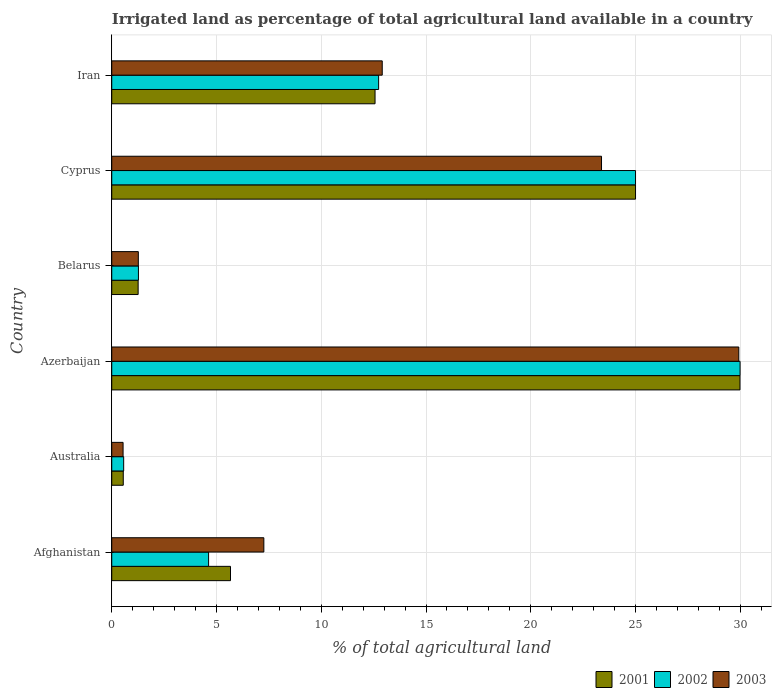How many groups of bars are there?
Your answer should be compact. 6. Are the number of bars per tick equal to the number of legend labels?
Keep it short and to the point. Yes. Are the number of bars on each tick of the Y-axis equal?
Make the answer very short. Yes. How many bars are there on the 6th tick from the top?
Your answer should be compact. 3. How many bars are there on the 6th tick from the bottom?
Offer a very short reply. 3. What is the label of the 3rd group of bars from the top?
Offer a terse response. Belarus. What is the percentage of irrigated land in 2003 in Cyprus?
Ensure brevity in your answer.  23.38. Across all countries, what is the maximum percentage of irrigated land in 2002?
Offer a terse response. 29.99. Across all countries, what is the minimum percentage of irrigated land in 2001?
Give a very brief answer. 0.55. In which country was the percentage of irrigated land in 2001 maximum?
Give a very brief answer. Azerbaijan. What is the total percentage of irrigated land in 2001 in the graph?
Ensure brevity in your answer.  75.03. What is the difference between the percentage of irrigated land in 2001 in Azerbaijan and that in Iran?
Ensure brevity in your answer.  17.42. What is the difference between the percentage of irrigated land in 2001 in Belarus and the percentage of irrigated land in 2002 in Cyprus?
Provide a short and direct response. -23.74. What is the average percentage of irrigated land in 2003 per country?
Keep it short and to the point. 12.55. What is the difference between the percentage of irrigated land in 2003 and percentage of irrigated land in 2002 in Cyprus?
Ensure brevity in your answer.  -1.62. What is the ratio of the percentage of irrigated land in 2003 in Azerbaijan to that in Iran?
Keep it short and to the point. 2.32. Is the difference between the percentage of irrigated land in 2003 in Azerbaijan and Cyprus greater than the difference between the percentage of irrigated land in 2002 in Azerbaijan and Cyprus?
Provide a succinct answer. Yes. What is the difference between the highest and the second highest percentage of irrigated land in 2002?
Provide a succinct answer. 4.99. What is the difference between the highest and the lowest percentage of irrigated land in 2001?
Your response must be concise. 29.44. Is the sum of the percentage of irrigated land in 2002 in Belarus and Cyprus greater than the maximum percentage of irrigated land in 2003 across all countries?
Give a very brief answer. No. What does the 2nd bar from the top in Afghanistan represents?
Make the answer very short. 2002. How many bars are there?
Give a very brief answer. 18. How many countries are there in the graph?
Provide a succinct answer. 6. Are the values on the major ticks of X-axis written in scientific E-notation?
Provide a short and direct response. No. Does the graph contain grids?
Offer a very short reply. Yes. Where does the legend appear in the graph?
Provide a short and direct response. Bottom right. What is the title of the graph?
Ensure brevity in your answer.  Irrigated land as percentage of total agricultural land available in a country. What is the label or title of the X-axis?
Offer a terse response. % of total agricultural land. What is the label or title of the Y-axis?
Offer a terse response. Country. What is the % of total agricultural land of 2001 in Afghanistan?
Offer a terse response. 5.67. What is the % of total agricultural land of 2002 in Afghanistan?
Offer a very short reply. 4.62. What is the % of total agricultural land in 2003 in Afghanistan?
Provide a succinct answer. 7.26. What is the % of total agricultural land of 2001 in Australia?
Your answer should be compact. 0.55. What is the % of total agricultural land in 2002 in Australia?
Offer a very short reply. 0.57. What is the % of total agricultural land in 2003 in Australia?
Provide a succinct answer. 0.54. What is the % of total agricultural land in 2001 in Azerbaijan?
Your answer should be very brief. 29.99. What is the % of total agricultural land in 2002 in Azerbaijan?
Provide a short and direct response. 29.99. What is the % of total agricultural land of 2003 in Azerbaijan?
Provide a succinct answer. 29.93. What is the % of total agricultural land of 2001 in Belarus?
Give a very brief answer. 1.26. What is the % of total agricultural land of 2002 in Belarus?
Your answer should be very brief. 1.27. What is the % of total agricultural land of 2003 in Belarus?
Your answer should be compact. 1.27. What is the % of total agricultural land of 2001 in Cyprus?
Your response must be concise. 25. What is the % of total agricultural land in 2002 in Cyprus?
Ensure brevity in your answer.  25. What is the % of total agricultural land of 2003 in Cyprus?
Keep it short and to the point. 23.38. What is the % of total agricultural land in 2001 in Iran?
Give a very brief answer. 12.57. What is the % of total agricultural land of 2002 in Iran?
Keep it short and to the point. 12.74. What is the % of total agricultural land in 2003 in Iran?
Ensure brevity in your answer.  12.91. Across all countries, what is the maximum % of total agricultural land of 2001?
Ensure brevity in your answer.  29.99. Across all countries, what is the maximum % of total agricultural land of 2002?
Provide a short and direct response. 29.99. Across all countries, what is the maximum % of total agricultural land of 2003?
Offer a terse response. 29.93. Across all countries, what is the minimum % of total agricultural land of 2001?
Your response must be concise. 0.55. Across all countries, what is the minimum % of total agricultural land in 2002?
Your answer should be compact. 0.57. Across all countries, what is the minimum % of total agricultural land of 2003?
Offer a terse response. 0.54. What is the total % of total agricultural land in 2001 in the graph?
Your answer should be compact. 75.03. What is the total % of total agricultural land in 2002 in the graph?
Make the answer very short. 74.19. What is the total % of total agricultural land of 2003 in the graph?
Give a very brief answer. 75.29. What is the difference between the % of total agricultural land of 2001 in Afghanistan and that in Australia?
Make the answer very short. 5.12. What is the difference between the % of total agricultural land in 2002 in Afghanistan and that in Australia?
Give a very brief answer. 4.05. What is the difference between the % of total agricultural land in 2003 in Afghanistan and that in Australia?
Ensure brevity in your answer.  6.72. What is the difference between the % of total agricultural land of 2001 in Afghanistan and that in Azerbaijan?
Your answer should be compact. -24.32. What is the difference between the % of total agricultural land of 2002 in Afghanistan and that in Azerbaijan?
Your answer should be compact. -25.37. What is the difference between the % of total agricultural land in 2003 in Afghanistan and that in Azerbaijan?
Your answer should be compact. -22.67. What is the difference between the % of total agricultural land in 2001 in Afghanistan and that in Belarus?
Provide a short and direct response. 4.41. What is the difference between the % of total agricultural land of 2002 in Afghanistan and that in Belarus?
Ensure brevity in your answer.  3.35. What is the difference between the % of total agricultural land of 2003 in Afghanistan and that in Belarus?
Make the answer very short. 5.99. What is the difference between the % of total agricultural land of 2001 in Afghanistan and that in Cyprus?
Offer a very short reply. -19.33. What is the difference between the % of total agricultural land of 2002 in Afghanistan and that in Cyprus?
Provide a succinct answer. -20.38. What is the difference between the % of total agricultural land in 2003 in Afghanistan and that in Cyprus?
Give a very brief answer. -16.12. What is the difference between the % of total agricultural land in 2001 in Afghanistan and that in Iran?
Give a very brief answer. -6.9. What is the difference between the % of total agricultural land of 2002 in Afghanistan and that in Iran?
Provide a short and direct response. -8.12. What is the difference between the % of total agricultural land in 2003 in Afghanistan and that in Iran?
Keep it short and to the point. -5.65. What is the difference between the % of total agricultural land of 2001 in Australia and that in Azerbaijan?
Provide a short and direct response. -29.44. What is the difference between the % of total agricultural land in 2002 in Australia and that in Azerbaijan?
Make the answer very short. -29.42. What is the difference between the % of total agricultural land in 2003 in Australia and that in Azerbaijan?
Your response must be concise. -29.39. What is the difference between the % of total agricultural land of 2001 in Australia and that in Belarus?
Provide a succinct answer. -0.71. What is the difference between the % of total agricultural land of 2002 in Australia and that in Belarus?
Ensure brevity in your answer.  -0.7. What is the difference between the % of total agricultural land of 2003 in Australia and that in Belarus?
Your answer should be very brief. -0.73. What is the difference between the % of total agricultural land in 2001 in Australia and that in Cyprus?
Ensure brevity in your answer.  -24.45. What is the difference between the % of total agricultural land in 2002 in Australia and that in Cyprus?
Offer a very short reply. -24.43. What is the difference between the % of total agricultural land of 2003 in Australia and that in Cyprus?
Give a very brief answer. -22.84. What is the difference between the % of total agricultural land of 2001 in Australia and that in Iran?
Your response must be concise. -12.02. What is the difference between the % of total agricultural land of 2002 in Australia and that in Iran?
Keep it short and to the point. -12.17. What is the difference between the % of total agricultural land in 2003 in Australia and that in Iran?
Make the answer very short. -12.37. What is the difference between the % of total agricultural land of 2001 in Azerbaijan and that in Belarus?
Offer a very short reply. 28.73. What is the difference between the % of total agricultural land of 2002 in Azerbaijan and that in Belarus?
Ensure brevity in your answer.  28.72. What is the difference between the % of total agricultural land of 2003 in Azerbaijan and that in Belarus?
Ensure brevity in your answer.  28.66. What is the difference between the % of total agricultural land in 2001 in Azerbaijan and that in Cyprus?
Keep it short and to the point. 4.99. What is the difference between the % of total agricultural land of 2002 in Azerbaijan and that in Cyprus?
Make the answer very short. 4.99. What is the difference between the % of total agricultural land of 2003 in Azerbaijan and that in Cyprus?
Your answer should be compact. 6.55. What is the difference between the % of total agricultural land in 2001 in Azerbaijan and that in Iran?
Keep it short and to the point. 17.42. What is the difference between the % of total agricultural land of 2002 in Azerbaijan and that in Iran?
Keep it short and to the point. 17.25. What is the difference between the % of total agricultural land of 2003 in Azerbaijan and that in Iran?
Your answer should be compact. 17.02. What is the difference between the % of total agricultural land in 2001 in Belarus and that in Cyprus?
Offer a very short reply. -23.74. What is the difference between the % of total agricultural land of 2002 in Belarus and that in Cyprus?
Provide a short and direct response. -23.73. What is the difference between the % of total agricultural land of 2003 in Belarus and that in Cyprus?
Provide a succinct answer. -22.11. What is the difference between the % of total agricultural land of 2001 in Belarus and that in Iran?
Make the answer very short. -11.31. What is the difference between the % of total agricultural land in 2002 in Belarus and that in Iran?
Provide a succinct answer. -11.46. What is the difference between the % of total agricultural land of 2003 in Belarus and that in Iran?
Provide a succinct answer. -11.64. What is the difference between the % of total agricultural land of 2001 in Cyprus and that in Iran?
Your answer should be very brief. 12.43. What is the difference between the % of total agricultural land in 2002 in Cyprus and that in Iran?
Your response must be concise. 12.26. What is the difference between the % of total agricultural land in 2003 in Cyprus and that in Iran?
Give a very brief answer. 10.47. What is the difference between the % of total agricultural land of 2001 in Afghanistan and the % of total agricultural land of 2002 in Australia?
Provide a succinct answer. 5.1. What is the difference between the % of total agricultural land of 2001 in Afghanistan and the % of total agricultural land of 2003 in Australia?
Give a very brief answer. 5.13. What is the difference between the % of total agricultural land of 2002 in Afghanistan and the % of total agricultural land of 2003 in Australia?
Your answer should be very brief. 4.08. What is the difference between the % of total agricultural land of 2001 in Afghanistan and the % of total agricultural land of 2002 in Azerbaijan?
Offer a very short reply. -24.32. What is the difference between the % of total agricultural land of 2001 in Afghanistan and the % of total agricultural land of 2003 in Azerbaijan?
Make the answer very short. -24.26. What is the difference between the % of total agricultural land of 2002 in Afghanistan and the % of total agricultural land of 2003 in Azerbaijan?
Make the answer very short. -25.31. What is the difference between the % of total agricultural land of 2001 in Afghanistan and the % of total agricultural land of 2002 in Belarus?
Provide a succinct answer. 4.39. What is the difference between the % of total agricultural land of 2001 in Afghanistan and the % of total agricultural land of 2003 in Belarus?
Provide a short and direct response. 4.4. What is the difference between the % of total agricultural land in 2002 in Afghanistan and the % of total agricultural land in 2003 in Belarus?
Offer a terse response. 3.35. What is the difference between the % of total agricultural land in 2001 in Afghanistan and the % of total agricultural land in 2002 in Cyprus?
Your response must be concise. -19.33. What is the difference between the % of total agricultural land in 2001 in Afghanistan and the % of total agricultural land in 2003 in Cyprus?
Your answer should be compact. -17.71. What is the difference between the % of total agricultural land in 2002 in Afghanistan and the % of total agricultural land in 2003 in Cyprus?
Your answer should be compact. -18.75. What is the difference between the % of total agricultural land of 2001 in Afghanistan and the % of total agricultural land of 2002 in Iran?
Provide a short and direct response. -7.07. What is the difference between the % of total agricultural land of 2001 in Afghanistan and the % of total agricultural land of 2003 in Iran?
Your response must be concise. -7.24. What is the difference between the % of total agricultural land in 2002 in Afghanistan and the % of total agricultural land in 2003 in Iran?
Keep it short and to the point. -8.29. What is the difference between the % of total agricultural land in 2001 in Australia and the % of total agricultural land in 2002 in Azerbaijan?
Your answer should be compact. -29.44. What is the difference between the % of total agricultural land of 2001 in Australia and the % of total agricultural land of 2003 in Azerbaijan?
Keep it short and to the point. -29.38. What is the difference between the % of total agricultural land in 2002 in Australia and the % of total agricultural land in 2003 in Azerbaijan?
Offer a very short reply. -29.36. What is the difference between the % of total agricultural land of 2001 in Australia and the % of total agricultural land of 2002 in Belarus?
Offer a very short reply. -0.72. What is the difference between the % of total agricultural land in 2001 in Australia and the % of total agricultural land in 2003 in Belarus?
Ensure brevity in your answer.  -0.72. What is the difference between the % of total agricultural land in 2002 in Australia and the % of total agricultural land in 2003 in Belarus?
Provide a short and direct response. -0.7. What is the difference between the % of total agricultural land in 2001 in Australia and the % of total agricultural land in 2002 in Cyprus?
Provide a short and direct response. -24.45. What is the difference between the % of total agricultural land of 2001 in Australia and the % of total agricultural land of 2003 in Cyprus?
Ensure brevity in your answer.  -22.83. What is the difference between the % of total agricultural land of 2002 in Australia and the % of total agricultural land of 2003 in Cyprus?
Provide a short and direct response. -22.81. What is the difference between the % of total agricultural land of 2001 in Australia and the % of total agricultural land of 2002 in Iran?
Make the answer very short. -12.19. What is the difference between the % of total agricultural land of 2001 in Australia and the % of total agricultural land of 2003 in Iran?
Give a very brief answer. -12.36. What is the difference between the % of total agricultural land of 2002 in Australia and the % of total agricultural land of 2003 in Iran?
Give a very brief answer. -12.34. What is the difference between the % of total agricultural land in 2001 in Azerbaijan and the % of total agricultural land in 2002 in Belarus?
Offer a terse response. 28.71. What is the difference between the % of total agricultural land in 2001 in Azerbaijan and the % of total agricultural land in 2003 in Belarus?
Your response must be concise. 28.72. What is the difference between the % of total agricultural land of 2002 in Azerbaijan and the % of total agricultural land of 2003 in Belarus?
Your answer should be very brief. 28.72. What is the difference between the % of total agricultural land in 2001 in Azerbaijan and the % of total agricultural land in 2002 in Cyprus?
Your answer should be compact. 4.99. What is the difference between the % of total agricultural land in 2001 in Azerbaijan and the % of total agricultural land in 2003 in Cyprus?
Offer a very short reply. 6.61. What is the difference between the % of total agricultural land of 2002 in Azerbaijan and the % of total agricultural land of 2003 in Cyprus?
Your answer should be very brief. 6.61. What is the difference between the % of total agricultural land in 2001 in Azerbaijan and the % of total agricultural land in 2002 in Iran?
Keep it short and to the point. 17.25. What is the difference between the % of total agricultural land in 2001 in Azerbaijan and the % of total agricultural land in 2003 in Iran?
Make the answer very short. 17.08. What is the difference between the % of total agricultural land of 2002 in Azerbaijan and the % of total agricultural land of 2003 in Iran?
Your response must be concise. 17.08. What is the difference between the % of total agricultural land of 2001 in Belarus and the % of total agricultural land of 2002 in Cyprus?
Your answer should be compact. -23.74. What is the difference between the % of total agricultural land in 2001 in Belarus and the % of total agricultural land in 2003 in Cyprus?
Your answer should be compact. -22.12. What is the difference between the % of total agricultural land in 2002 in Belarus and the % of total agricultural land in 2003 in Cyprus?
Give a very brief answer. -22.1. What is the difference between the % of total agricultural land in 2001 in Belarus and the % of total agricultural land in 2002 in Iran?
Your answer should be very brief. -11.48. What is the difference between the % of total agricultural land in 2001 in Belarus and the % of total agricultural land in 2003 in Iran?
Provide a short and direct response. -11.65. What is the difference between the % of total agricultural land of 2002 in Belarus and the % of total agricultural land of 2003 in Iran?
Give a very brief answer. -11.64. What is the difference between the % of total agricultural land in 2001 in Cyprus and the % of total agricultural land in 2002 in Iran?
Ensure brevity in your answer.  12.26. What is the difference between the % of total agricultural land in 2001 in Cyprus and the % of total agricultural land in 2003 in Iran?
Your answer should be compact. 12.09. What is the difference between the % of total agricultural land in 2002 in Cyprus and the % of total agricultural land in 2003 in Iran?
Offer a terse response. 12.09. What is the average % of total agricultural land in 2001 per country?
Ensure brevity in your answer.  12.51. What is the average % of total agricultural land in 2002 per country?
Ensure brevity in your answer.  12.37. What is the average % of total agricultural land in 2003 per country?
Give a very brief answer. 12.55. What is the difference between the % of total agricultural land in 2001 and % of total agricultural land in 2002 in Afghanistan?
Keep it short and to the point. 1.05. What is the difference between the % of total agricultural land in 2001 and % of total agricultural land in 2003 in Afghanistan?
Provide a short and direct response. -1.59. What is the difference between the % of total agricultural land of 2002 and % of total agricultural land of 2003 in Afghanistan?
Offer a terse response. -2.64. What is the difference between the % of total agricultural land in 2001 and % of total agricultural land in 2002 in Australia?
Your answer should be compact. -0.02. What is the difference between the % of total agricultural land in 2001 and % of total agricultural land in 2003 in Australia?
Offer a very short reply. 0.01. What is the difference between the % of total agricultural land of 2002 and % of total agricultural land of 2003 in Australia?
Offer a terse response. 0.03. What is the difference between the % of total agricultural land in 2001 and % of total agricultural land in 2002 in Azerbaijan?
Your response must be concise. -0. What is the difference between the % of total agricultural land of 2001 and % of total agricultural land of 2003 in Azerbaijan?
Keep it short and to the point. 0.06. What is the difference between the % of total agricultural land in 2002 and % of total agricultural land in 2003 in Azerbaijan?
Provide a short and direct response. 0.06. What is the difference between the % of total agricultural land of 2001 and % of total agricultural land of 2002 in Belarus?
Give a very brief answer. -0.01. What is the difference between the % of total agricultural land in 2001 and % of total agricultural land in 2003 in Belarus?
Your response must be concise. -0.01. What is the difference between the % of total agricultural land of 2002 and % of total agricultural land of 2003 in Belarus?
Give a very brief answer. 0.01. What is the difference between the % of total agricultural land of 2001 and % of total agricultural land of 2003 in Cyprus?
Offer a terse response. 1.62. What is the difference between the % of total agricultural land in 2002 and % of total agricultural land in 2003 in Cyprus?
Keep it short and to the point. 1.62. What is the difference between the % of total agricultural land of 2001 and % of total agricultural land of 2002 in Iran?
Your answer should be very brief. -0.17. What is the difference between the % of total agricultural land of 2001 and % of total agricultural land of 2003 in Iran?
Make the answer very short. -0.34. What is the difference between the % of total agricultural land of 2002 and % of total agricultural land of 2003 in Iran?
Offer a very short reply. -0.17. What is the ratio of the % of total agricultural land in 2001 in Afghanistan to that in Australia?
Provide a short and direct response. 10.31. What is the ratio of the % of total agricultural land in 2002 in Afghanistan to that in Australia?
Keep it short and to the point. 8.12. What is the ratio of the % of total agricultural land in 2003 in Afghanistan to that in Australia?
Ensure brevity in your answer.  13.42. What is the ratio of the % of total agricultural land of 2001 in Afghanistan to that in Azerbaijan?
Give a very brief answer. 0.19. What is the ratio of the % of total agricultural land in 2002 in Afghanistan to that in Azerbaijan?
Your response must be concise. 0.15. What is the ratio of the % of total agricultural land in 2003 in Afghanistan to that in Azerbaijan?
Ensure brevity in your answer.  0.24. What is the ratio of the % of total agricultural land of 2001 in Afghanistan to that in Belarus?
Give a very brief answer. 4.5. What is the ratio of the % of total agricultural land of 2002 in Afghanistan to that in Belarus?
Offer a terse response. 3.63. What is the ratio of the % of total agricultural land of 2003 in Afghanistan to that in Belarus?
Provide a succinct answer. 5.72. What is the ratio of the % of total agricultural land in 2001 in Afghanistan to that in Cyprus?
Your response must be concise. 0.23. What is the ratio of the % of total agricultural land of 2002 in Afghanistan to that in Cyprus?
Your response must be concise. 0.18. What is the ratio of the % of total agricultural land of 2003 in Afghanistan to that in Cyprus?
Provide a short and direct response. 0.31. What is the ratio of the % of total agricultural land in 2001 in Afghanistan to that in Iran?
Your answer should be very brief. 0.45. What is the ratio of the % of total agricultural land in 2002 in Afghanistan to that in Iran?
Provide a short and direct response. 0.36. What is the ratio of the % of total agricultural land in 2003 in Afghanistan to that in Iran?
Your response must be concise. 0.56. What is the ratio of the % of total agricultural land in 2001 in Australia to that in Azerbaijan?
Keep it short and to the point. 0.02. What is the ratio of the % of total agricultural land in 2002 in Australia to that in Azerbaijan?
Your answer should be compact. 0.02. What is the ratio of the % of total agricultural land of 2003 in Australia to that in Azerbaijan?
Provide a short and direct response. 0.02. What is the ratio of the % of total agricultural land of 2001 in Australia to that in Belarus?
Provide a short and direct response. 0.44. What is the ratio of the % of total agricultural land of 2002 in Australia to that in Belarus?
Ensure brevity in your answer.  0.45. What is the ratio of the % of total agricultural land of 2003 in Australia to that in Belarus?
Offer a terse response. 0.43. What is the ratio of the % of total agricultural land in 2001 in Australia to that in Cyprus?
Your answer should be compact. 0.02. What is the ratio of the % of total agricultural land in 2002 in Australia to that in Cyprus?
Keep it short and to the point. 0.02. What is the ratio of the % of total agricultural land of 2003 in Australia to that in Cyprus?
Offer a very short reply. 0.02. What is the ratio of the % of total agricultural land in 2001 in Australia to that in Iran?
Ensure brevity in your answer.  0.04. What is the ratio of the % of total agricultural land of 2002 in Australia to that in Iran?
Ensure brevity in your answer.  0.04. What is the ratio of the % of total agricultural land of 2003 in Australia to that in Iran?
Offer a very short reply. 0.04. What is the ratio of the % of total agricultural land of 2001 in Azerbaijan to that in Belarus?
Provide a succinct answer. 23.8. What is the ratio of the % of total agricultural land in 2002 in Azerbaijan to that in Belarus?
Make the answer very short. 23.54. What is the ratio of the % of total agricultural land of 2003 in Azerbaijan to that in Belarus?
Provide a succinct answer. 23.59. What is the ratio of the % of total agricultural land of 2001 in Azerbaijan to that in Cyprus?
Give a very brief answer. 1.2. What is the ratio of the % of total agricultural land of 2002 in Azerbaijan to that in Cyprus?
Provide a succinct answer. 1.2. What is the ratio of the % of total agricultural land in 2003 in Azerbaijan to that in Cyprus?
Provide a short and direct response. 1.28. What is the ratio of the % of total agricultural land of 2001 in Azerbaijan to that in Iran?
Keep it short and to the point. 2.39. What is the ratio of the % of total agricultural land in 2002 in Azerbaijan to that in Iran?
Offer a very short reply. 2.35. What is the ratio of the % of total agricultural land in 2003 in Azerbaijan to that in Iran?
Offer a very short reply. 2.32. What is the ratio of the % of total agricultural land in 2001 in Belarus to that in Cyprus?
Make the answer very short. 0.05. What is the ratio of the % of total agricultural land of 2002 in Belarus to that in Cyprus?
Offer a very short reply. 0.05. What is the ratio of the % of total agricultural land in 2003 in Belarus to that in Cyprus?
Give a very brief answer. 0.05. What is the ratio of the % of total agricultural land of 2001 in Belarus to that in Iran?
Your answer should be very brief. 0.1. What is the ratio of the % of total agricultural land of 2003 in Belarus to that in Iran?
Provide a short and direct response. 0.1. What is the ratio of the % of total agricultural land in 2001 in Cyprus to that in Iran?
Ensure brevity in your answer.  1.99. What is the ratio of the % of total agricultural land in 2002 in Cyprus to that in Iran?
Provide a succinct answer. 1.96. What is the ratio of the % of total agricultural land in 2003 in Cyprus to that in Iran?
Ensure brevity in your answer.  1.81. What is the difference between the highest and the second highest % of total agricultural land of 2001?
Ensure brevity in your answer.  4.99. What is the difference between the highest and the second highest % of total agricultural land of 2002?
Your answer should be very brief. 4.99. What is the difference between the highest and the second highest % of total agricultural land of 2003?
Your answer should be very brief. 6.55. What is the difference between the highest and the lowest % of total agricultural land of 2001?
Offer a terse response. 29.44. What is the difference between the highest and the lowest % of total agricultural land in 2002?
Your answer should be compact. 29.42. What is the difference between the highest and the lowest % of total agricultural land of 2003?
Offer a very short reply. 29.39. 